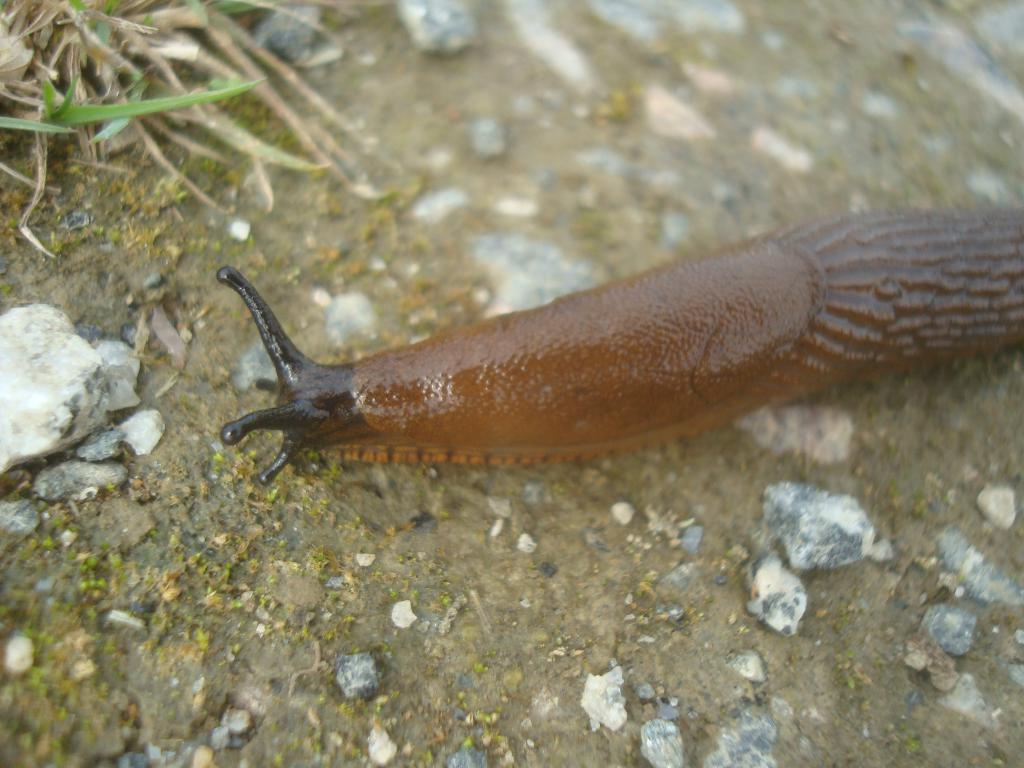What type of animal is in the image? There is a snail in the image. Where is the snail located? The snail is on the ground. Can you describe the position of the snail in the image? The snail is in the center of the image. What type of locket is the snail wearing for breakfast in the image? There is no locket or mention of breakfast in the image; it features a snail on the ground. 